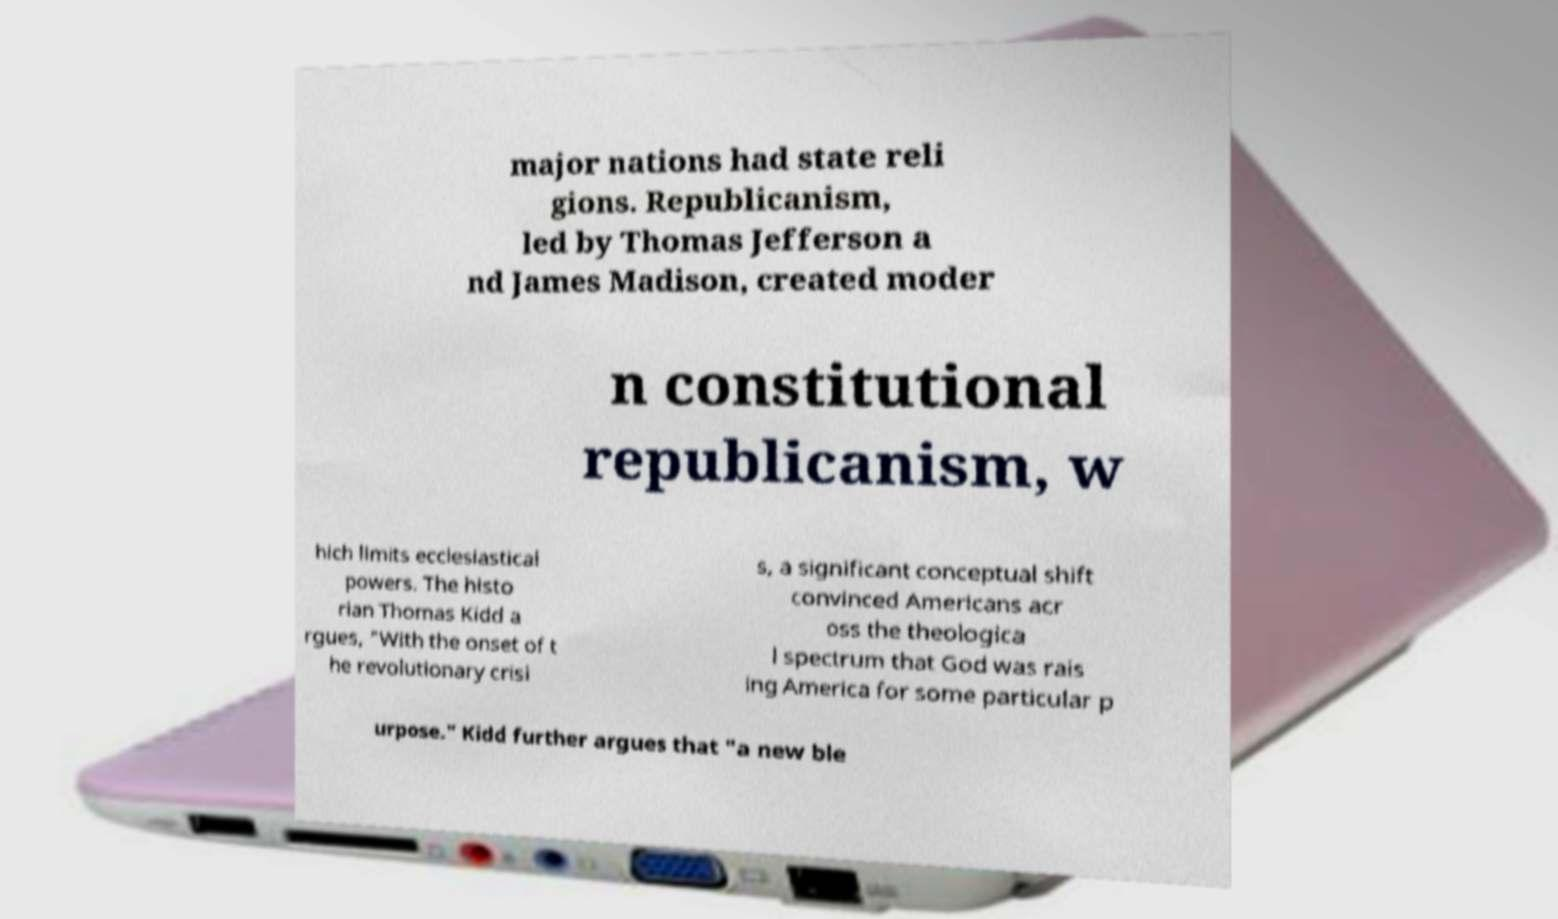Could you extract and type out the text from this image? major nations had state reli gions. Republicanism, led by Thomas Jefferson a nd James Madison, created moder n constitutional republicanism, w hich limits ecclesiastical powers. The histo rian Thomas Kidd a rgues, "With the onset of t he revolutionary crisi s, a significant conceptual shift convinced Americans acr oss the theologica l spectrum that God was rais ing America for some particular p urpose." Kidd further argues that "a new ble 